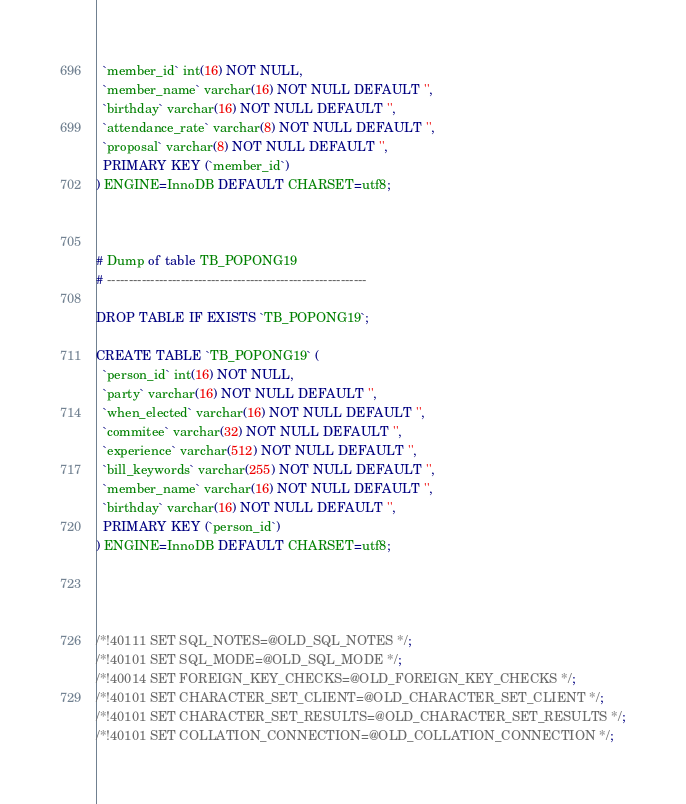<code> <loc_0><loc_0><loc_500><loc_500><_SQL_>  `member_id` int(16) NOT NULL,
  `member_name` varchar(16) NOT NULL DEFAULT '',
  `birthday` varchar(16) NOT NULL DEFAULT '',
  `attendance_rate` varchar(8) NOT NULL DEFAULT '',
  `proposal` varchar(8) NOT NULL DEFAULT '',
  PRIMARY KEY (`member_id`)
) ENGINE=InnoDB DEFAULT CHARSET=utf8;



# Dump of table TB_POPONG19
# ------------------------------------------------------------

DROP TABLE IF EXISTS `TB_POPONG19`;

CREATE TABLE `TB_POPONG19` (
  `person_id` int(16) NOT NULL,
  `party` varchar(16) NOT NULL DEFAULT '',
  `when_elected` varchar(16) NOT NULL DEFAULT '',
  `commitee` varchar(32) NOT NULL DEFAULT '',
  `experience` varchar(512) NOT NULL DEFAULT '',
  `bill_keywords` varchar(255) NOT NULL DEFAULT '',
  `member_name` varchar(16) NOT NULL DEFAULT '',
  `birthday` varchar(16) NOT NULL DEFAULT '',
  PRIMARY KEY (`person_id`)
) ENGINE=InnoDB DEFAULT CHARSET=utf8;




/*!40111 SET SQL_NOTES=@OLD_SQL_NOTES */;
/*!40101 SET SQL_MODE=@OLD_SQL_MODE */;
/*!40014 SET FOREIGN_KEY_CHECKS=@OLD_FOREIGN_KEY_CHECKS */;
/*!40101 SET CHARACTER_SET_CLIENT=@OLD_CHARACTER_SET_CLIENT */;
/*!40101 SET CHARACTER_SET_RESULTS=@OLD_CHARACTER_SET_RESULTS */;
/*!40101 SET COLLATION_CONNECTION=@OLD_COLLATION_CONNECTION */;
</code> 